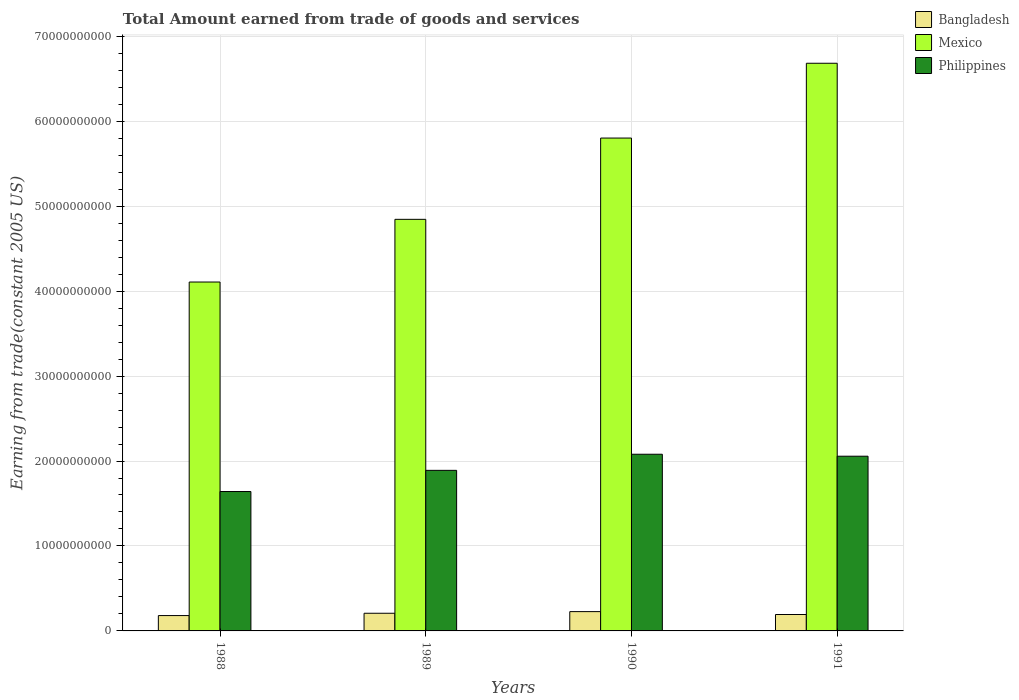How many different coloured bars are there?
Make the answer very short. 3. How many groups of bars are there?
Your answer should be compact. 4. Are the number of bars per tick equal to the number of legend labels?
Offer a very short reply. Yes. What is the label of the 3rd group of bars from the left?
Provide a succinct answer. 1990. In how many cases, is the number of bars for a given year not equal to the number of legend labels?
Ensure brevity in your answer.  0. What is the total amount earned by trading goods and services in Bangladesh in 1989?
Offer a very short reply. 2.08e+09. Across all years, what is the maximum total amount earned by trading goods and services in Bangladesh?
Make the answer very short. 2.27e+09. Across all years, what is the minimum total amount earned by trading goods and services in Bangladesh?
Your response must be concise. 1.81e+09. In which year was the total amount earned by trading goods and services in Bangladesh minimum?
Ensure brevity in your answer.  1988. What is the total total amount earned by trading goods and services in Bangladesh in the graph?
Offer a very short reply. 8.09e+09. What is the difference between the total amount earned by trading goods and services in Philippines in 1988 and that in 1989?
Provide a succinct answer. -2.49e+09. What is the difference between the total amount earned by trading goods and services in Bangladesh in 1988 and the total amount earned by trading goods and services in Philippines in 1989?
Give a very brief answer. -1.71e+1. What is the average total amount earned by trading goods and services in Philippines per year?
Provide a short and direct response. 1.92e+1. In the year 1991, what is the difference between the total amount earned by trading goods and services in Mexico and total amount earned by trading goods and services in Bangladesh?
Ensure brevity in your answer.  6.49e+1. In how many years, is the total amount earned by trading goods and services in Philippines greater than 64000000000 US$?
Provide a short and direct response. 0. What is the ratio of the total amount earned by trading goods and services in Bangladesh in 1988 to that in 1991?
Give a very brief answer. 0.94. What is the difference between the highest and the second highest total amount earned by trading goods and services in Philippines?
Provide a short and direct response. 2.33e+08. What is the difference between the highest and the lowest total amount earned by trading goods and services in Philippines?
Your response must be concise. 4.39e+09. In how many years, is the total amount earned by trading goods and services in Mexico greater than the average total amount earned by trading goods and services in Mexico taken over all years?
Make the answer very short. 2. Is the sum of the total amount earned by trading goods and services in Mexico in 1988 and 1989 greater than the maximum total amount earned by trading goods and services in Philippines across all years?
Provide a succinct answer. Yes. What does the 2nd bar from the right in 1988 represents?
Your response must be concise. Mexico. Is it the case that in every year, the sum of the total amount earned by trading goods and services in Mexico and total amount earned by trading goods and services in Philippines is greater than the total amount earned by trading goods and services in Bangladesh?
Ensure brevity in your answer.  Yes. How many years are there in the graph?
Your response must be concise. 4. Are the values on the major ticks of Y-axis written in scientific E-notation?
Ensure brevity in your answer.  No. Where does the legend appear in the graph?
Your answer should be compact. Top right. How many legend labels are there?
Offer a terse response. 3. What is the title of the graph?
Keep it short and to the point. Total Amount earned from trade of goods and services. Does "Portugal" appear as one of the legend labels in the graph?
Give a very brief answer. No. What is the label or title of the X-axis?
Provide a succinct answer. Years. What is the label or title of the Y-axis?
Offer a very short reply. Earning from trade(constant 2005 US). What is the Earning from trade(constant 2005 US) in Bangladesh in 1988?
Provide a short and direct response. 1.81e+09. What is the Earning from trade(constant 2005 US) in Mexico in 1988?
Give a very brief answer. 4.11e+1. What is the Earning from trade(constant 2005 US) in Philippines in 1988?
Your response must be concise. 1.64e+1. What is the Earning from trade(constant 2005 US) in Bangladesh in 1989?
Offer a very short reply. 2.08e+09. What is the Earning from trade(constant 2005 US) of Mexico in 1989?
Your response must be concise. 4.84e+1. What is the Earning from trade(constant 2005 US) in Philippines in 1989?
Your answer should be very brief. 1.89e+1. What is the Earning from trade(constant 2005 US) of Bangladesh in 1990?
Keep it short and to the point. 2.27e+09. What is the Earning from trade(constant 2005 US) in Mexico in 1990?
Give a very brief answer. 5.80e+1. What is the Earning from trade(constant 2005 US) in Philippines in 1990?
Offer a terse response. 2.08e+1. What is the Earning from trade(constant 2005 US) of Bangladesh in 1991?
Make the answer very short. 1.93e+09. What is the Earning from trade(constant 2005 US) in Mexico in 1991?
Offer a very short reply. 6.68e+1. What is the Earning from trade(constant 2005 US) in Philippines in 1991?
Give a very brief answer. 2.06e+1. Across all years, what is the maximum Earning from trade(constant 2005 US) in Bangladesh?
Make the answer very short. 2.27e+09. Across all years, what is the maximum Earning from trade(constant 2005 US) in Mexico?
Keep it short and to the point. 6.68e+1. Across all years, what is the maximum Earning from trade(constant 2005 US) of Philippines?
Keep it short and to the point. 2.08e+1. Across all years, what is the minimum Earning from trade(constant 2005 US) of Bangladesh?
Your response must be concise. 1.81e+09. Across all years, what is the minimum Earning from trade(constant 2005 US) of Mexico?
Provide a short and direct response. 4.11e+1. Across all years, what is the minimum Earning from trade(constant 2005 US) in Philippines?
Offer a very short reply. 1.64e+1. What is the total Earning from trade(constant 2005 US) of Bangladesh in the graph?
Offer a terse response. 8.09e+09. What is the total Earning from trade(constant 2005 US) in Mexico in the graph?
Your answer should be compact. 2.14e+11. What is the total Earning from trade(constant 2005 US) in Philippines in the graph?
Make the answer very short. 7.67e+1. What is the difference between the Earning from trade(constant 2005 US) in Bangladesh in 1988 and that in 1989?
Offer a terse response. -2.72e+08. What is the difference between the Earning from trade(constant 2005 US) in Mexico in 1988 and that in 1989?
Keep it short and to the point. -7.38e+09. What is the difference between the Earning from trade(constant 2005 US) in Philippines in 1988 and that in 1989?
Keep it short and to the point. -2.49e+09. What is the difference between the Earning from trade(constant 2005 US) in Bangladesh in 1988 and that in 1990?
Provide a short and direct response. -4.66e+08. What is the difference between the Earning from trade(constant 2005 US) in Mexico in 1988 and that in 1990?
Ensure brevity in your answer.  -1.69e+1. What is the difference between the Earning from trade(constant 2005 US) in Philippines in 1988 and that in 1990?
Keep it short and to the point. -4.39e+09. What is the difference between the Earning from trade(constant 2005 US) of Bangladesh in 1988 and that in 1991?
Make the answer very short. -1.24e+08. What is the difference between the Earning from trade(constant 2005 US) of Mexico in 1988 and that in 1991?
Provide a short and direct response. -2.58e+1. What is the difference between the Earning from trade(constant 2005 US) of Philippines in 1988 and that in 1991?
Your response must be concise. -4.16e+09. What is the difference between the Earning from trade(constant 2005 US) of Bangladesh in 1989 and that in 1990?
Keep it short and to the point. -1.94e+08. What is the difference between the Earning from trade(constant 2005 US) in Mexico in 1989 and that in 1990?
Your answer should be compact. -9.57e+09. What is the difference between the Earning from trade(constant 2005 US) in Philippines in 1989 and that in 1990?
Provide a succinct answer. -1.90e+09. What is the difference between the Earning from trade(constant 2005 US) of Bangladesh in 1989 and that in 1991?
Ensure brevity in your answer.  1.48e+08. What is the difference between the Earning from trade(constant 2005 US) of Mexico in 1989 and that in 1991?
Offer a very short reply. -1.84e+1. What is the difference between the Earning from trade(constant 2005 US) of Philippines in 1989 and that in 1991?
Make the answer very short. -1.67e+09. What is the difference between the Earning from trade(constant 2005 US) of Bangladesh in 1990 and that in 1991?
Offer a terse response. 3.41e+08. What is the difference between the Earning from trade(constant 2005 US) of Mexico in 1990 and that in 1991?
Make the answer very short. -8.81e+09. What is the difference between the Earning from trade(constant 2005 US) of Philippines in 1990 and that in 1991?
Provide a succinct answer. 2.33e+08. What is the difference between the Earning from trade(constant 2005 US) of Bangladesh in 1988 and the Earning from trade(constant 2005 US) of Mexico in 1989?
Make the answer very short. -4.66e+1. What is the difference between the Earning from trade(constant 2005 US) in Bangladesh in 1988 and the Earning from trade(constant 2005 US) in Philippines in 1989?
Your response must be concise. -1.71e+1. What is the difference between the Earning from trade(constant 2005 US) of Mexico in 1988 and the Earning from trade(constant 2005 US) of Philippines in 1989?
Your response must be concise. 2.22e+1. What is the difference between the Earning from trade(constant 2005 US) of Bangladesh in 1988 and the Earning from trade(constant 2005 US) of Mexico in 1990?
Provide a short and direct response. -5.62e+1. What is the difference between the Earning from trade(constant 2005 US) in Bangladesh in 1988 and the Earning from trade(constant 2005 US) in Philippines in 1990?
Offer a very short reply. -1.90e+1. What is the difference between the Earning from trade(constant 2005 US) in Mexico in 1988 and the Earning from trade(constant 2005 US) in Philippines in 1990?
Keep it short and to the point. 2.03e+1. What is the difference between the Earning from trade(constant 2005 US) of Bangladesh in 1988 and the Earning from trade(constant 2005 US) of Mexico in 1991?
Give a very brief answer. -6.50e+1. What is the difference between the Earning from trade(constant 2005 US) in Bangladesh in 1988 and the Earning from trade(constant 2005 US) in Philippines in 1991?
Offer a very short reply. -1.88e+1. What is the difference between the Earning from trade(constant 2005 US) in Mexico in 1988 and the Earning from trade(constant 2005 US) in Philippines in 1991?
Your answer should be very brief. 2.05e+1. What is the difference between the Earning from trade(constant 2005 US) in Bangladesh in 1989 and the Earning from trade(constant 2005 US) in Mexico in 1990?
Give a very brief answer. -5.59e+1. What is the difference between the Earning from trade(constant 2005 US) of Bangladesh in 1989 and the Earning from trade(constant 2005 US) of Philippines in 1990?
Make the answer very short. -1.87e+1. What is the difference between the Earning from trade(constant 2005 US) in Mexico in 1989 and the Earning from trade(constant 2005 US) in Philippines in 1990?
Your response must be concise. 2.77e+1. What is the difference between the Earning from trade(constant 2005 US) of Bangladesh in 1989 and the Earning from trade(constant 2005 US) of Mexico in 1991?
Offer a very short reply. -6.47e+1. What is the difference between the Earning from trade(constant 2005 US) in Bangladesh in 1989 and the Earning from trade(constant 2005 US) in Philippines in 1991?
Provide a succinct answer. -1.85e+1. What is the difference between the Earning from trade(constant 2005 US) of Mexico in 1989 and the Earning from trade(constant 2005 US) of Philippines in 1991?
Your answer should be compact. 2.79e+1. What is the difference between the Earning from trade(constant 2005 US) of Bangladesh in 1990 and the Earning from trade(constant 2005 US) of Mexico in 1991?
Provide a succinct answer. -6.45e+1. What is the difference between the Earning from trade(constant 2005 US) of Bangladesh in 1990 and the Earning from trade(constant 2005 US) of Philippines in 1991?
Your answer should be very brief. -1.83e+1. What is the difference between the Earning from trade(constant 2005 US) in Mexico in 1990 and the Earning from trade(constant 2005 US) in Philippines in 1991?
Offer a very short reply. 3.75e+1. What is the average Earning from trade(constant 2005 US) in Bangladesh per year?
Your answer should be very brief. 2.02e+09. What is the average Earning from trade(constant 2005 US) of Mexico per year?
Provide a short and direct response. 5.36e+1. What is the average Earning from trade(constant 2005 US) in Philippines per year?
Provide a short and direct response. 1.92e+1. In the year 1988, what is the difference between the Earning from trade(constant 2005 US) of Bangladesh and Earning from trade(constant 2005 US) of Mexico?
Offer a very short reply. -3.93e+1. In the year 1988, what is the difference between the Earning from trade(constant 2005 US) in Bangladesh and Earning from trade(constant 2005 US) in Philippines?
Keep it short and to the point. -1.46e+1. In the year 1988, what is the difference between the Earning from trade(constant 2005 US) of Mexico and Earning from trade(constant 2005 US) of Philippines?
Your answer should be very brief. 2.47e+1. In the year 1989, what is the difference between the Earning from trade(constant 2005 US) of Bangladesh and Earning from trade(constant 2005 US) of Mexico?
Provide a short and direct response. -4.64e+1. In the year 1989, what is the difference between the Earning from trade(constant 2005 US) in Bangladesh and Earning from trade(constant 2005 US) in Philippines?
Make the answer very short. -1.68e+1. In the year 1989, what is the difference between the Earning from trade(constant 2005 US) of Mexico and Earning from trade(constant 2005 US) of Philippines?
Provide a short and direct response. 2.95e+1. In the year 1990, what is the difference between the Earning from trade(constant 2005 US) of Bangladesh and Earning from trade(constant 2005 US) of Mexico?
Make the answer very short. -5.57e+1. In the year 1990, what is the difference between the Earning from trade(constant 2005 US) in Bangladesh and Earning from trade(constant 2005 US) in Philippines?
Your response must be concise. -1.85e+1. In the year 1990, what is the difference between the Earning from trade(constant 2005 US) of Mexico and Earning from trade(constant 2005 US) of Philippines?
Offer a very short reply. 3.72e+1. In the year 1991, what is the difference between the Earning from trade(constant 2005 US) in Bangladesh and Earning from trade(constant 2005 US) in Mexico?
Provide a succinct answer. -6.49e+1. In the year 1991, what is the difference between the Earning from trade(constant 2005 US) of Bangladesh and Earning from trade(constant 2005 US) of Philippines?
Provide a succinct answer. -1.86e+1. In the year 1991, what is the difference between the Earning from trade(constant 2005 US) of Mexico and Earning from trade(constant 2005 US) of Philippines?
Keep it short and to the point. 4.63e+1. What is the ratio of the Earning from trade(constant 2005 US) in Bangladesh in 1988 to that in 1989?
Offer a terse response. 0.87. What is the ratio of the Earning from trade(constant 2005 US) in Mexico in 1988 to that in 1989?
Your answer should be very brief. 0.85. What is the ratio of the Earning from trade(constant 2005 US) in Philippines in 1988 to that in 1989?
Keep it short and to the point. 0.87. What is the ratio of the Earning from trade(constant 2005 US) of Bangladesh in 1988 to that in 1990?
Offer a terse response. 0.8. What is the ratio of the Earning from trade(constant 2005 US) in Mexico in 1988 to that in 1990?
Keep it short and to the point. 0.71. What is the ratio of the Earning from trade(constant 2005 US) of Philippines in 1988 to that in 1990?
Offer a very short reply. 0.79. What is the ratio of the Earning from trade(constant 2005 US) in Bangladesh in 1988 to that in 1991?
Your answer should be very brief. 0.94. What is the ratio of the Earning from trade(constant 2005 US) in Mexico in 1988 to that in 1991?
Offer a terse response. 0.61. What is the ratio of the Earning from trade(constant 2005 US) in Philippines in 1988 to that in 1991?
Ensure brevity in your answer.  0.8. What is the ratio of the Earning from trade(constant 2005 US) of Bangladesh in 1989 to that in 1990?
Give a very brief answer. 0.91. What is the ratio of the Earning from trade(constant 2005 US) in Mexico in 1989 to that in 1990?
Your answer should be compact. 0.84. What is the ratio of the Earning from trade(constant 2005 US) in Philippines in 1989 to that in 1990?
Your response must be concise. 0.91. What is the ratio of the Earning from trade(constant 2005 US) of Bangladesh in 1989 to that in 1991?
Keep it short and to the point. 1.08. What is the ratio of the Earning from trade(constant 2005 US) of Mexico in 1989 to that in 1991?
Ensure brevity in your answer.  0.73. What is the ratio of the Earning from trade(constant 2005 US) of Philippines in 1989 to that in 1991?
Your answer should be compact. 0.92. What is the ratio of the Earning from trade(constant 2005 US) of Bangladesh in 1990 to that in 1991?
Your answer should be very brief. 1.18. What is the ratio of the Earning from trade(constant 2005 US) of Mexico in 1990 to that in 1991?
Provide a short and direct response. 0.87. What is the ratio of the Earning from trade(constant 2005 US) of Philippines in 1990 to that in 1991?
Your response must be concise. 1.01. What is the difference between the highest and the second highest Earning from trade(constant 2005 US) of Bangladesh?
Your response must be concise. 1.94e+08. What is the difference between the highest and the second highest Earning from trade(constant 2005 US) of Mexico?
Offer a very short reply. 8.81e+09. What is the difference between the highest and the second highest Earning from trade(constant 2005 US) in Philippines?
Provide a succinct answer. 2.33e+08. What is the difference between the highest and the lowest Earning from trade(constant 2005 US) of Bangladesh?
Your answer should be compact. 4.66e+08. What is the difference between the highest and the lowest Earning from trade(constant 2005 US) of Mexico?
Keep it short and to the point. 2.58e+1. What is the difference between the highest and the lowest Earning from trade(constant 2005 US) in Philippines?
Provide a succinct answer. 4.39e+09. 